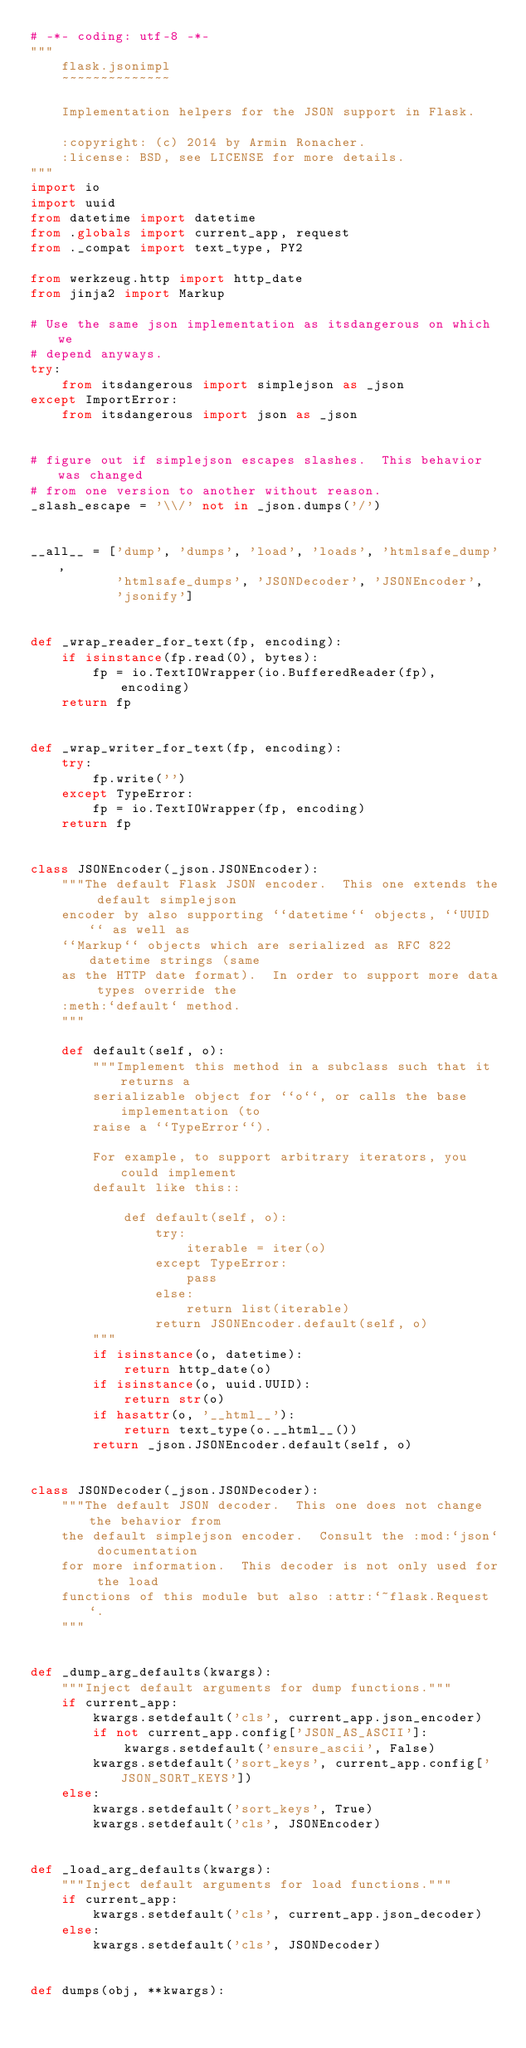Convert code to text. <code><loc_0><loc_0><loc_500><loc_500><_Python_># -*- coding: utf-8 -*-
"""
    flask.jsonimpl
    ~~~~~~~~~~~~~~

    Implementation helpers for the JSON support in Flask.

    :copyright: (c) 2014 by Armin Ronacher.
    :license: BSD, see LICENSE for more details.
"""
import io
import uuid
from datetime import datetime
from .globals import current_app, request
from ._compat import text_type, PY2

from werkzeug.http import http_date
from jinja2 import Markup

# Use the same json implementation as itsdangerous on which we
# depend anyways.
try:
    from itsdangerous import simplejson as _json
except ImportError:
    from itsdangerous import json as _json


# figure out if simplejson escapes slashes.  This behavior was changed
# from one version to another without reason.
_slash_escape = '\\/' not in _json.dumps('/')


__all__ = ['dump', 'dumps', 'load', 'loads', 'htmlsafe_dump',
           'htmlsafe_dumps', 'JSONDecoder', 'JSONEncoder',
           'jsonify']


def _wrap_reader_for_text(fp, encoding):
    if isinstance(fp.read(0), bytes):
        fp = io.TextIOWrapper(io.BufferedReader(fp), encoding)
    return fp


def _wrap_writer_for_text(fp, encoding):
    try:
        fp.write('')
    except TypeError:
        fp = io.TextIOWrapper(fp, encoding)
    return fp


class JSONEncoder(_json.JSONEncoder):
    """The default Flask JSON encoder.  This one extends the default simplejson
    encoder by also supporting ``datetime`` objects, ``UUID`` as well as
    ``Markup`` objects which are serialized as RFC 822 datetime strings (same
    as the HTTP date format).  In order to support more data types override the
    :meth:`default` method.
    """

    def default(self, o):
        """Implement this method in a subclass such that it returns a
        serializable object for ``o``, or calls the base implementation (to
        raise a ``TypeError``).

        For example, to support arbitrary iterators, you could implement
        default like this::

            def default(self, o):
                try:
                    iterable = iter(o)
                except TypeError:
                    pass
                else:
                    return list(iterable)
                return JSONEncoder.default(self, o)
        """
        if isinstance(o, datetime):
            return http_date(o)
        if isinstance(o, uuid.UUID):
            return str(o)
        if hasattr(o, '__html__'):
            return text_type(o.__html__())
        return _json.JSONEncoder.default(self, o)


class JSONDecoder(_json.JSONDecoder):
    """The default JSON decoder.  This one does not change the behavior from
    the default simplejson encoder.  Consult the :mod:`json` documentation
    for more information.  This decoder is not only used for the load
    functions of this module but also :attr:`~flask.Request`.
    """


def _dump_arg_defaults(kwargs):
    """Inject default arguments for dump functions."""
    if current_app:
        kwargs.setdefault('cls', current_app.json_encoder)
        if not current_app.config['JSON_AS_ASCII']:
            kwargs.setdefault('ensure_ascii', False)
        kwargs.setdefault('sort_keys', current_app.config['JSON_SORT_KEYS'])
    else:
        kwargs.setdefault('sort_keys', True)
        kwargs.setdefault('cls', JSONEncoder)


def _load_arg_defaults(kwargs):
    """Inject default arguments for load functions."""
    if current_app:
        kwargs.setdefault('cls', current_app.json_decoder)
    else:
        kwargs.setdefault('cls', JSONDecoder)


def dumps(obj, **kwargs):</code> 